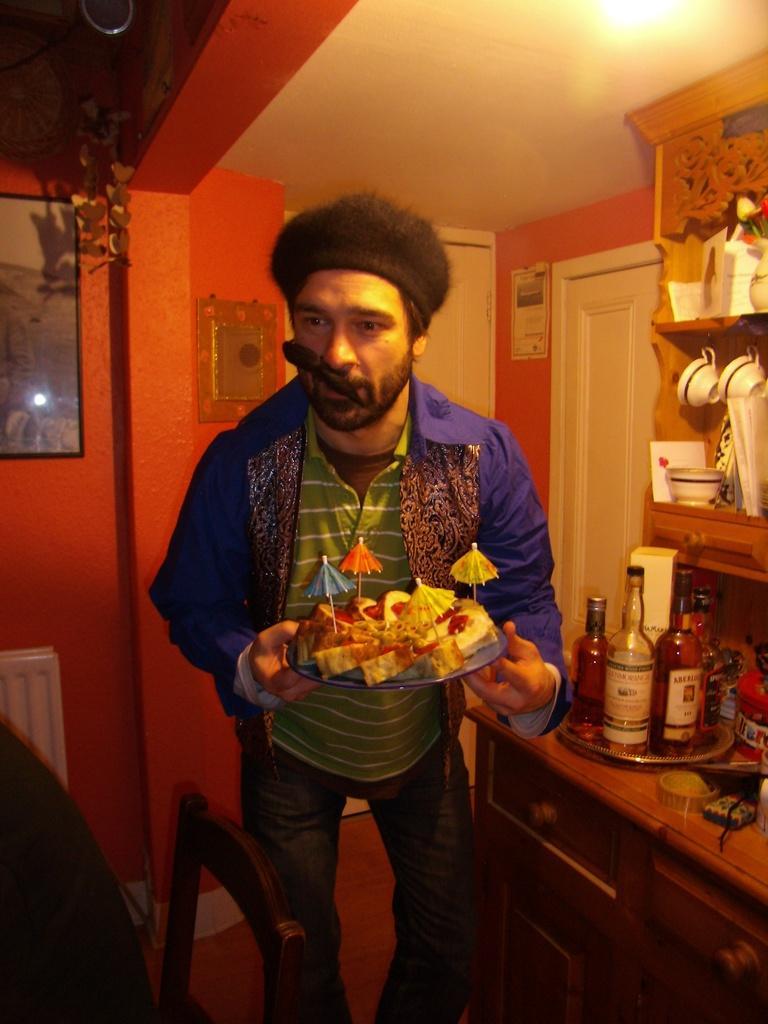How would you summarize this image in a sentence or two? Here we can see one man standing and holding cake pieces on a plate in his hand. He wore black colour cap. On the background we can see photo frames, posters over a wall. This is a door. At the right side of the picture we can see a cupboard where cups and bottles are arranged. This is a desk. This is a chair. 